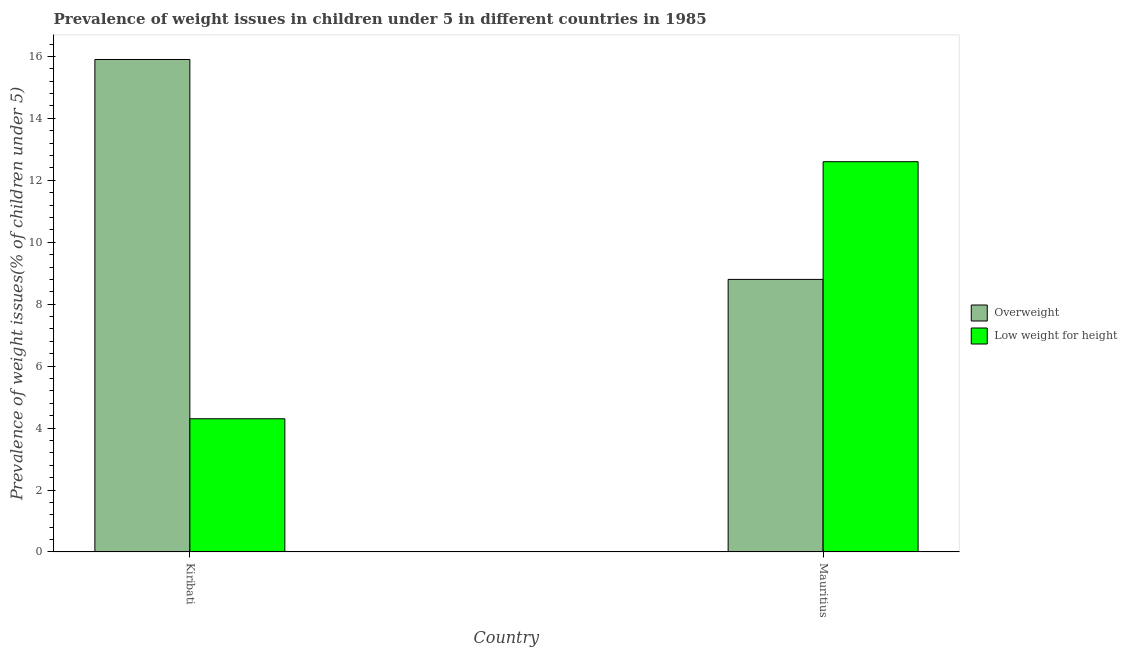How many groups of bars are there?
Keep it short and to the point. 2. Are the number of bars per tick equal to the number of legend labels?
Give a very brief answer. Yes. Are the number of bars on each tick of the X-axis equal?
Offer a terse response. Yes. How many bars are there on the 1st tick from the right?
Provide a succinct answer. 2. What is the label of the 1st group of bars from the left?
Your answer should be very brief. Kiribati. What is the percentage of underweight children in Mauritius?
Provide a short and direct response. 12.6. Across all countries, what is the maximum percentage of overweight children?
Offer a terse response. 15.9. Across all countries, what is the minimum percentage of underweight children?
Your answer should be compact. 4.3. In which country was the percentage of underweight children maximum?
Your answer should be compact. Mauritius. In which country was the percentage of overweight children minimum?
Make the answer very short. Mauritius. What is the total percentage of underweight children in the graph?
Ensure brevity in your answer.  16.9. What is the difference between the percentage of underweight children in Kiribati and that in Mauritius?
Provide a succinct answer. -8.3. What is the difference between the percentage of overweight children in Kiribati and the percentage of underweight children in Mauritius?
Offer a very short reply. 3.3. What is the average percentage of underweight children per country?
Provide a short and direct response. 8.45. What is the difference between the percentage of underweight children and percentage of overweight children in Kiribati?
Provide a succinct answer. -11.6. In how many countries, is the percentage of overweight children greater than 10.4 %?
Give a very brief answer. 1. What is the ratio of the percentage of underweight children in Kiribati to that in Mauritius?
Your answer should be very brief. 0.34. Is the percentage of underweight children in Kiribati less than that in Mauritius?
Your response must be concise. Yes. What does the 2nd bar from the left in Kiribati represents?
Give a very brief answer. Low weight for height. What does the 2nd bar from the right in Kiribati represents?
Provide a short and direct response. Overweight. How many bars are there?
Keep it short and to the point. 4. How many countries are there in the graph?
Provide a short and direct response. 2. How are the legend labels stacked?
Offer a terse response. Vertical. What is the title of the graph?
Provide a short and direct response. Prevalence of weight issues in children under 5 in different countries in 1985. Does "Merchandise imports" appear as one of the legend labels in the graph?
Keep it short and to the point. No. What is the label or title of the X-axis?
Offer a very short reply. Country. What is the label or title of the Y-axis?
Give a very brief answer. Prevalence of weight issues(% of children under 5). What is the Prevalence of weight issues(% of children under 5) of Overweight in Kiribati?
Ensure brevity in your answer.  15.9. What is the Prevalence of weight issues(% of children under 5) of Low weight for height in Kiribati?
Your response must be concise. 4.3. What is the Prevalence of weight issues(% of children under 5) of Overweight in Mauritius?
Keep it short and to the point. 8.8. What is the Prevalence of weight issues(% of children under 5) in Low weight for height in Mauritius?
Keep it short and to the point. 12.6. Across all countries, what is the maximum Prevalence of weight issues(% of children under 5) of Overweight?
Offer a very short reply. 15.9. Across all countries, what is the maximum Prevalence of weight issues(% of children under 5) of Low weight for height?
Your answer should be compact. 12.6. Across all countries, what is the minimum Prevalence of weight issues(% of children under 5) of Overweight?
Offer a terse response. 8.8. Across all countries, what is the minimum Prevalence of weight issues(% of children under 5) in Low weight for height?
Your answer should be very brief. 4.3. What is the total Prevalence of weight issues(% of children under 5) of Overweight in the graph?
Offer a very short reply. 24.7. What is the difference between the Prevalence of weight issues(% of children under 5) of Overweight in Kiribati and that in Mauritius?
Your response must be concise. 7.1. What is the average Prevalence of weight issues(% of children under 5) of Overweight per country?
Make the answer very short. 12.35. What is the average Prevalence of weight issues(% of children under 5) in Low weight for height per country?
Provide a short and direct response. 8.45. What is the ratio of the Prevalence of weight issues(% of children under 5) in Overweight in Kiribati to that in Mauritius?
Your response must be concise. 1.81. What is the ratio of the Prevalence of weight issues(% of children under 5) in Low weight for height in Kiribati to that in Mauritius?
Keep it short and to the point. 0.34. What is the difference between the highest and the second highest Prevalence of weight issues(% of children under 5) in Low weight for height?
Your answer should be very brief. 8.3. What is the difference between the highest and the lowest Prevalence of weight issues(% of children under 5) of Overweight?
Give a very brief answer. 7.1. What is the difference between the highest and the lowest Prevalence of weight issues(% of children under 5) in Low weight for height?
Your response must be concise. 8.3. 